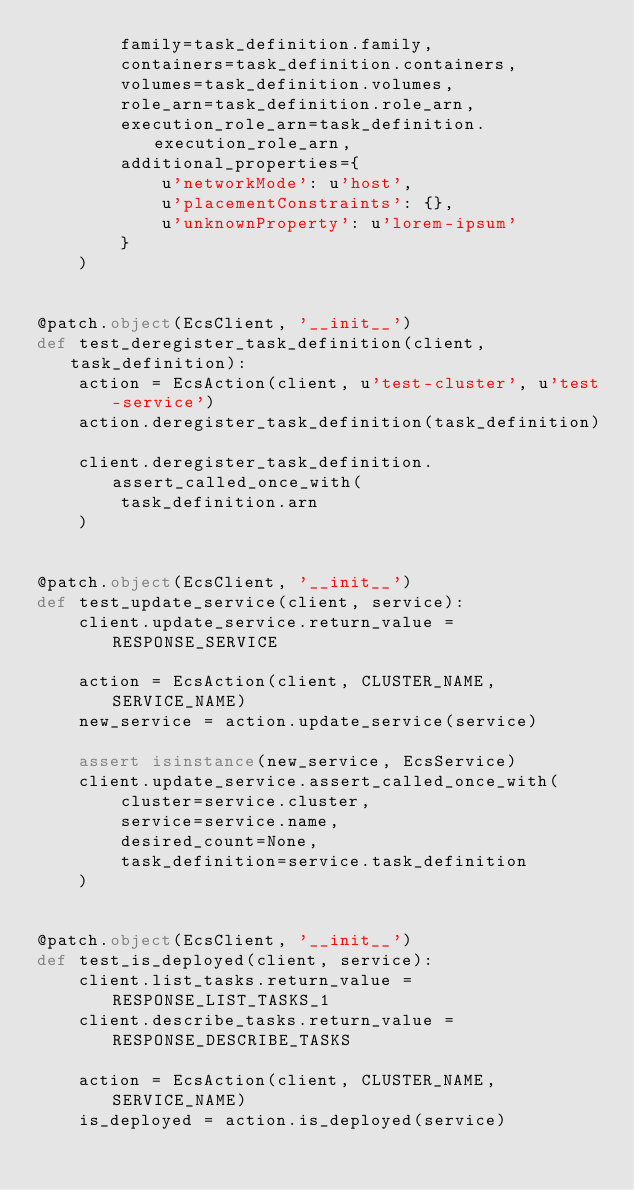<code> <loc_0><loc_0><loc_500><loc_500><_Python_>        family=task_definition.family,
        containers=task_definition.containers,
        volumes=task_definition.volumes,
        role_arn=task_definition.role_arn,
        execution_role_arn=task_definition.execution_role_arn,
        additional_properties={
            u'networkMode': u'host',
            u'placementConstraints': {},
            u'unknownProperty': u'lorem-ipsum'
        }
    )


@patch.object(EcsClient, '__init__')
def test_deregister_task_definition(client, task_definition):
    action = EcsAction(client, u'test-cluster', u'test-service')
    action.deregister_task_definition(task_definition)

    client.deregister_task_definition.assert_called_once_with(
        task_definition.arn
    )


@patch.object(EcsClient, '__init__')
def test_update_service(client, service):
    client.update_service.return_value = RESPONSE_SERVICE

    action = EcsAction(client, CLUSTER_NAME, SERVICE_NAME)
    new_service = action.update_service(service)

    assert isinstance(new_service, EcsService)
    client.update_service.assert_called_once_with(
        cluster=service.cluster,
        service=service.name,
        desired_count=None,
        task_definition=service.task_definition
    )


@patch.object(EcsClient, '__init__')
def test_is_deployed(client, service):
    client.list_tasks.return_value = RESPONSE_LIST_TASKS_1
    client.describe_tasks.return_value = RESPONSE_DESCRIBE_TASKS

    action = EcsAction(client, CLUSTER_NAME, SERVICE_NAME)
    is_deployed = action.is_deployed(service)
</code> 